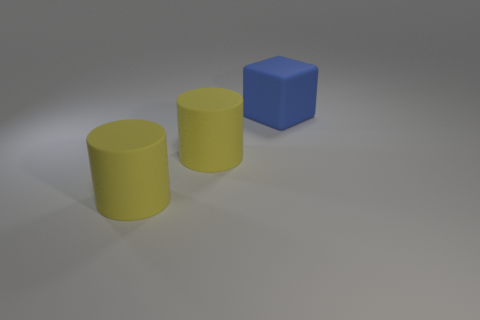Is the number of big red spheres less than the number of large blue matte blocks?
Ensure brevity in your answer.  Yes. What number of other objects are the same color as the matte block?
Ensure brevity in your answer.  0. How many yellow cylinders are there?
Your answer should be compact. 2. Are there fewer rubber things that are to the left of the big cube than brown metallic spheres?
Provide a succinct answer. No. Is there a brown cylinder of the same size as the rubber cube?
Make the answer very short. No. How big is the cube?
Your response must be concise. Large. How many blue objects are the same size as the blue cube?
Your answer should be compact. 0. Is there anything else of the same color as the big rubber cube?
Your response must be concise. No. How many gray things are either big rubber objects or cylinders?
Ensure brevity in your answer.  0. How many other objects are there of the same size as the blue thing?
Your answer should be very brief. 2. 